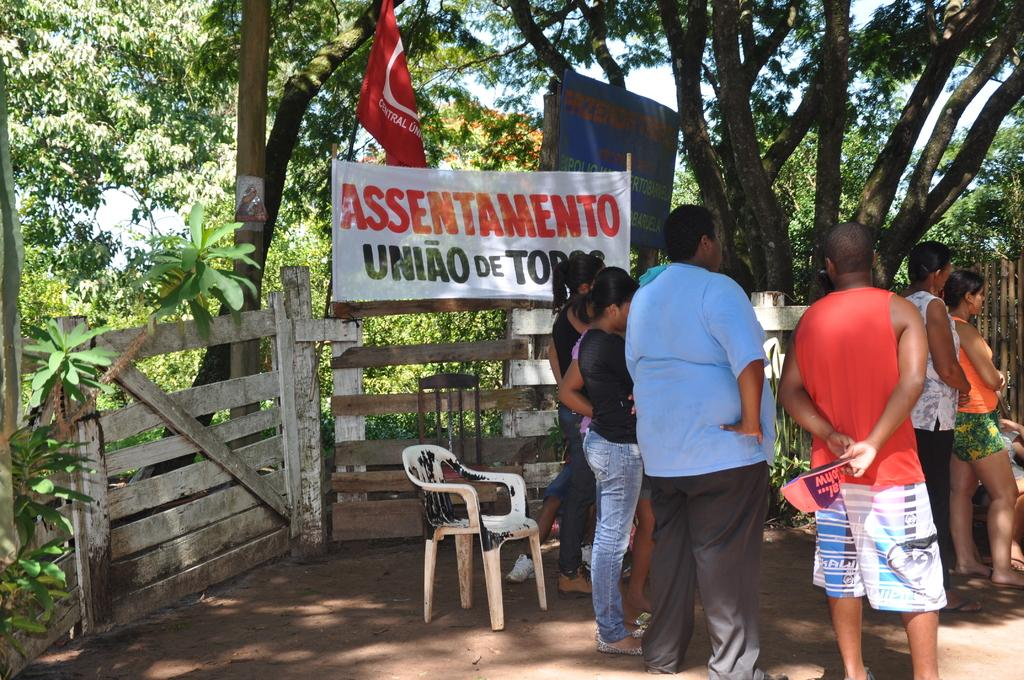How many people are in the image? There is a group of people standing in the image. What objects are on the ground in the image? There are two chairs on the ground in the image. What is the purpose of the fence in the image? The purpose of the fence in the image is not specified, but it could be for enclosing an area or providing a boundary. What can be seen in the background of the image? In the background of the image, there is a banner and a flag. Trees are also visible. What type of vegetation is visible in the background of the image? Trees are visible in the background of the image. How does the alley control the movement of the people in the image? There is no alley present in the image; it features a group of people, two chairs, a fence, a banner, a flag, and trees in the background. What type of head is visible on the people in the image? The image does not show the heads of the people, only their bodies. 